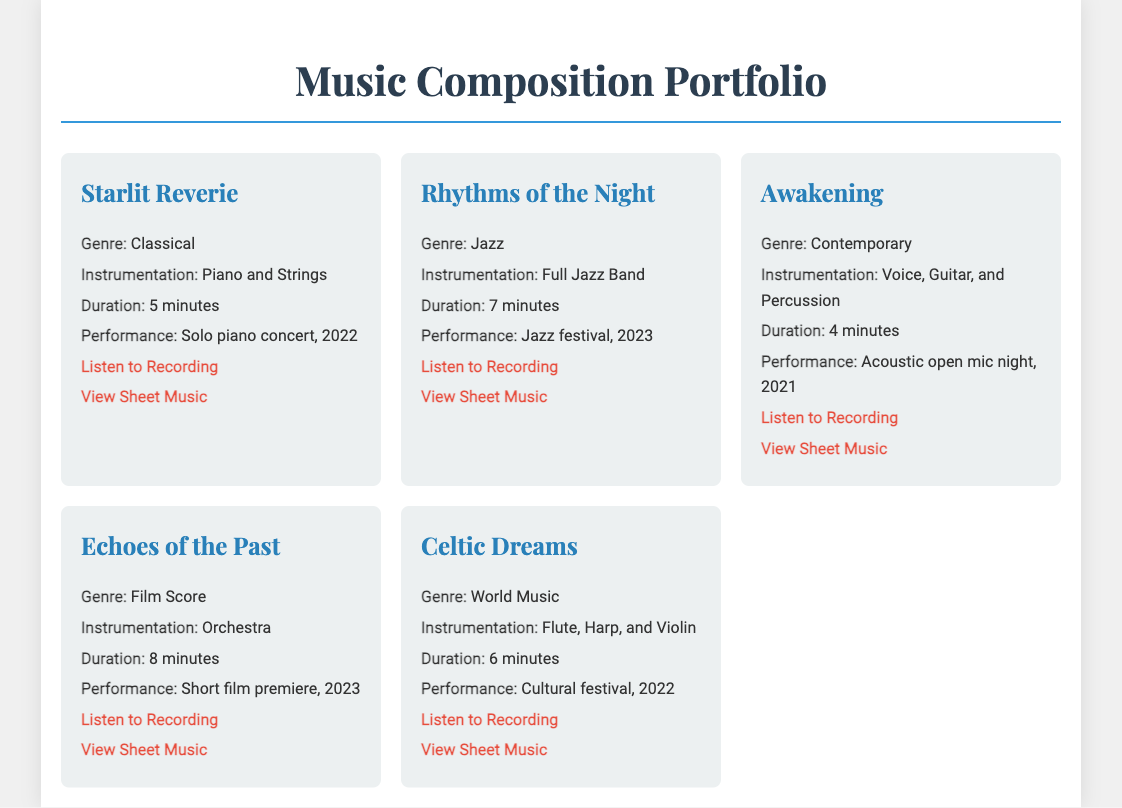What is the title of the first composition? The title of the first composition is mentioned in the document under "Starlit Reverie."
Answer: Starlit Reverie What is the genre of "Awakening"? The genre for "Awakening" can be found directly under its title in the document.
Answer: Contemporary How long is "Celtic Dreams"? The duration of "Celtic Dreams" is specified in the document after the instrumentation section.
Answer: 6 minutes What instrumentation is used in "Rhythms of the Night"? The instrumentation for "Rhythms of the Night" is provided in the composition details in the document.
Answer: Full Jazz Band In which year was "Echoes of the Past" performed? The year of the performance for "Echoes of the Past" is stated in the performance context in the document.
Answer: 2023 Which composition features Voice, Guitar, and Percussion? The specific composition featuring Voice, Guitar, and Percussion is listed in the document.
Answer: Awakening Which performance context does "Starlit Reverie" refer to? The performance context for "Starlit Reverie" can be found in the document and outlines where it took place.
Answer: Solo piano concert, 2022 How many minutes long is "Rhythms of the Night"? The duration for "Rhythms of the Night" is provided in the details in the document.
Answer: 7 minutes 